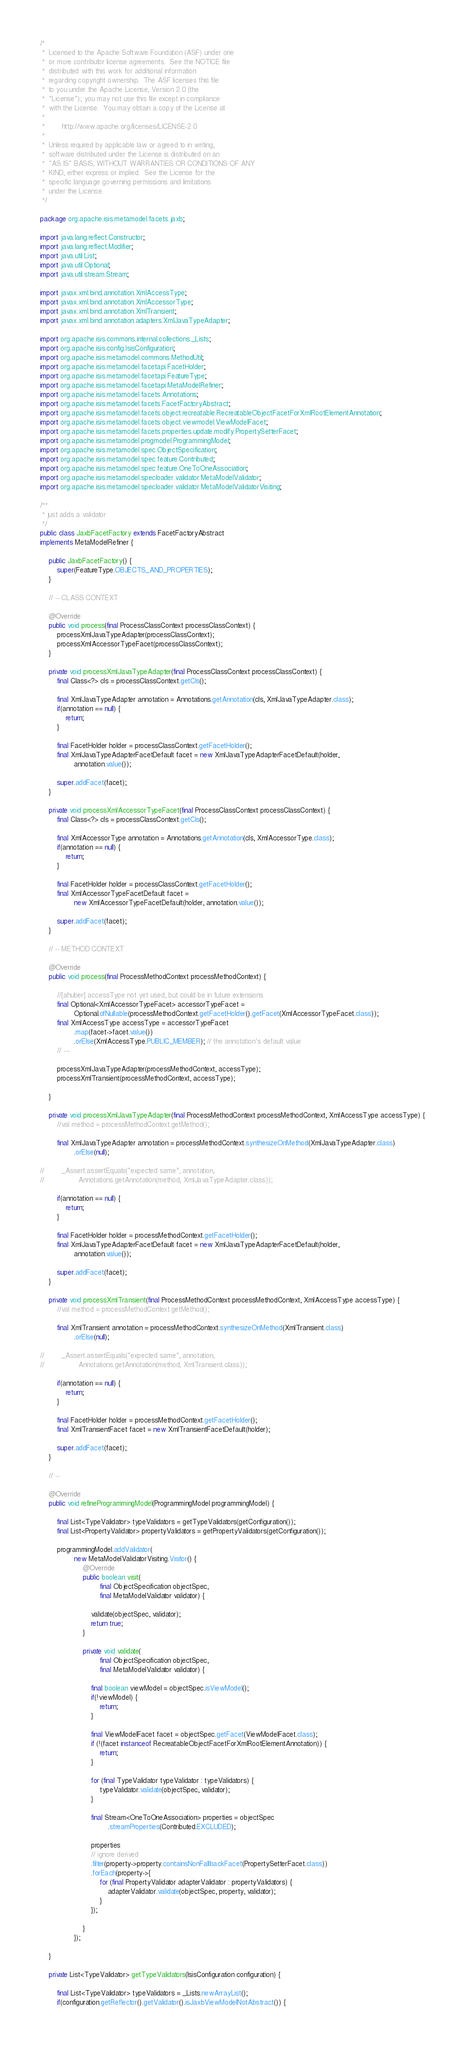<code> <loc_0><loc_0><loc_500><loc_500><_Java_>/*
 *  Licensed to the Apache Software Foundation (ASF) under one
 *  or more contributor license agreements.  See the NOTICE file
 *  distributed with this work for additional information
 *  regarding copyright ownership.  The ASF licenses this file
 *  to you under the Apache License, Version 2.0 (the
 *  "License"); you may not use this file except in compliance
 *  with the License.  You may obtain a copy of the License at
 *
 *        http://www.apache.org/licenses/LICENSE-2.0
 *
 *  Unless required by applicable law or agreed to in writing,
 *  software distributed under the License is distributed on an
 *  "AS IS" BASIS, WITHOUT WARRANTIES OR CONDITIONS OF ANY
 *  KIND, either express or implied.  See the License for the
 *  specific language governing permissions and limitations
 *  under the License.
 */

package org.apache.isis.metamodel.facets.jaxb;

import java.lang.reflect.Constructor;
import java.lang.reflect.Modifier;
import java.util.List;
import java.util.Optional;
import java.util.stream.Stream;

import javax.xml.bind.annotation.XmlAccessType;
import javax.xml.bind.annotation.XmlAccessorType;
import javax.xml.bind.annotation.XmlTransient;
import javax.xml.bind.annotation.adapters.XmlJavaTypeAdapter;

import org.apache.isis.commons.internal.collections._Lists;
import org.apache.isis.config.IsisConfiguration;
import org.apache.isis.metamodel.commons.MethodUtil;
import org.apache.isis.metamodel.facetapi.FacetHolder;
import org.apache.isis.metamodel.facetapi.FeatureType;
import org.apache.isis.metamodel.facetapi.MetaModelRefiner;
import org.apache.isis.metamodel.facets.Annotations;
import org.apache.isis.metamodel.facets.FacetFactoryAbstract;
import org.apache.isis.metamodel.facets.object.recreatable.RecreatableObjectFacetForXmlRootElementAnnotation;
import org.apache.isis.metamodel.facets.object.viewmodel.ViewModelFacet;
import org.apache.isis.metamodel.facets.properties.update.modify.PropertySetterFacet;
import org.apache.isis.metamodel.progmodel.ProgrammingModel;
import org.apache.isis.metamodel.spec.ObjectSpecification;
import org.apache.isis.metamodel.spec.feature.Contributed;
import org.apache.isis.metamodel.spec.feature.OneToOneAssociation;
import org.apache.isis.metamodel.specloader.validator.MetaModelValidator;
import org.apache.isis.metamodel.specloader.validator.MetaModelValidatorVisiting;

/**
 * just adds a validator
 */
public class JaxbFacetFactory extends FacetFactoryAbstract
implements MetaModelRefiner {

    public JaxbFacetFactory() {
        super(FeatureType.OBJECTS_AND_PROPERTIES);
    }

    // -- CLASS CONTEXT

    @Override
    public void process(final ProcessClassContext processClassContext) {
        processXmlJavaTypeAdapter(processClassContext);
        processXmlAccessorTypeFacet(processClassContext);
    }

    private void processXmlJavaTypeAdapter(final ProcessClassContext processClassContext) {
        final Class<?> cls = processClassContext.getCls();

        final XmlJavaTypeAdapter annotation = Annotations.getAnnotation(cls, XmlJavaTypeAdapter.class);
        if(annotation == null) {
            return;
        }

        final FacetHolder holder = processClassContext.getFacetHolder();
        final XmlJavaTypeAdapterFacetDefault facet = new XmlJavaTypeAdapterFacetDefault(holder,
                annotation.value());

        super.addFacet(facet);
    }

    private void processXmlAccessorTypeFacet(final ProcessClassContext processClassContext) {
        final Class<?> cls = processClassContext.getCls();

        final XmlAccessorType annotation = Annotations.getAnnotation(cls, XmlAccessorType.class);
        if(annotation == null) {
            return;
        }

        final FacetHolder holder = processClassContext.getFacetHolder();
        final XmlAccessorTypeFacetDefault facet =
                new XmlAccessorTypeFacetDefault(holder, annotation.value());

        super.addFacet(facet);
    }

    // -- METHOD CONTEXT

    @Override
    public void process(final ProcessMethodContext processMethodContext) {

        //[ahuber] accessType not yet used, but could be in future extensions
        final Optional<XmlAccessorTypeFacet> accessorTypeFacet =
                Optional.ofNullable(processMethodContext.getFacetHolder().getFacet(XmlAccessorTypeFacet.class));
        final XmlAccessType accessType = accessorTypeFacet
                .map(facet->facet.value())
                .orElse(XmlAccessType.PUBLIC_MEMBER); // the annotation's default value
        // ---

        processXmlJavaTypeAdapter(processMethodContext, accessType);
        processXmlTransient(processMethodContext, accessType);

    }

    private void processXmlJavaTypeAdapter(final ProcessMethodContext processMethodContext, XmlAccessType accessType) {
        //val method = processMethodContext.getMethod();
        
        final XmlJavaTypeAdapter annotation = processMethodContext.synthesizeOnMethod(XmlJavaTypeAdapter.class)
                .orElse(null);
                
//        _Assert.assertEquals("expected same", annotation,
//                Annotations.getAnnotation(method, XmlJavaTypeAdapter.class));
        
        if(annotation == null) {
            return;
        }

        final FacetHolder holder = processMethodContext.getFacetHolder();
        final XmlJavaTypeAdapterFacetDefault facet = new XmlJavaTypeAdapterFacetDefault(holder,
                annotation.value());

        super.addFacet(facet);
    }

    private void processXmlTransient(final ProcessMethodContext processMethodContext, XmlAccessType accessType) {
        //val method = processMethodContext.getMethod();

        final XmlTransient annotation = processMethodContext.synthesizeOnMethod(XmlTransient.class)
                .orElse(null);
                
//        _Assert.assertEquals("expected same", annotation,
//                Annotations.getAnnotation(method, XmlTransient.class));
        
        if(annotation == null) {
            return;
        }

        final FacetHolder holder = processMethodContext.getFacetHolder();
        final XmlTransientFacet facet = new XmlTransientFacetDefault(holder);

        super.addFacet(facet);
    }

    // --

    @Override
    public void refineProgrammingModel(ProgrammingModel programmingModel) {

        final List<TypeValidator> typeValidators = getTypeValidators(getConfiguration());
        final List<PropertyValidator> propertyValidators = getPropertyValidators(getConfiguration());

        programmingModel.addValidator(
                new MetaModelValidatorVisiting.Visitor() {
                    @Override
                    public boolean visit(
                            final ObjectSpecification objectSpec,
                            final MetaModelValidator validator) {

                        validate(objectSpec, validator);
                        return true;
                    }

                    private void validate(
                            final ObjectSpecification objectSpec,
                            final MetaModelValidator validator) {

                        final boolean viewModel = objectSpec.isViewModel();
                        if(!viewModel) {
                            return;
                        }

                        final ViewModelFacet facet = objectSpec.getFacet(ViewModelFacet.class);
                        if (!(facet instanceof RecreatableObjectFacetForXmlRootElementAnnotation)) {
                            return;
                        }

                        for (final TypeValidator typeValidator : typeValidators) {
                            typeValidator.validate(objectSpec, validator);
                        }

                        final Stream<OneToOneAssociation> properties = objectSpec
                                .streamProperties(Contributed.EXCLUDED);

                        properties
                        // ignore derived
                        .filter(property->property.containsNonFallbackFacet(PropertySetterFacet.class))
                        .forEach(property->{
                            for (final PropertyValidator adapterValidator : propertyValidators) {
                                adapterValidator.validate(objectSpec, property, validator);
                            }
                        });

                    }
                });
        
    }

    private List<TypeValidator> getTypeValidators(IsisConfiguration configuration) {

        final List<TypeValidator> typeValidators = _Lists.newArrayList();
        if(configuration.getReflector().getValidator().isJaxbViewModelNotAbstract()) {</code> 